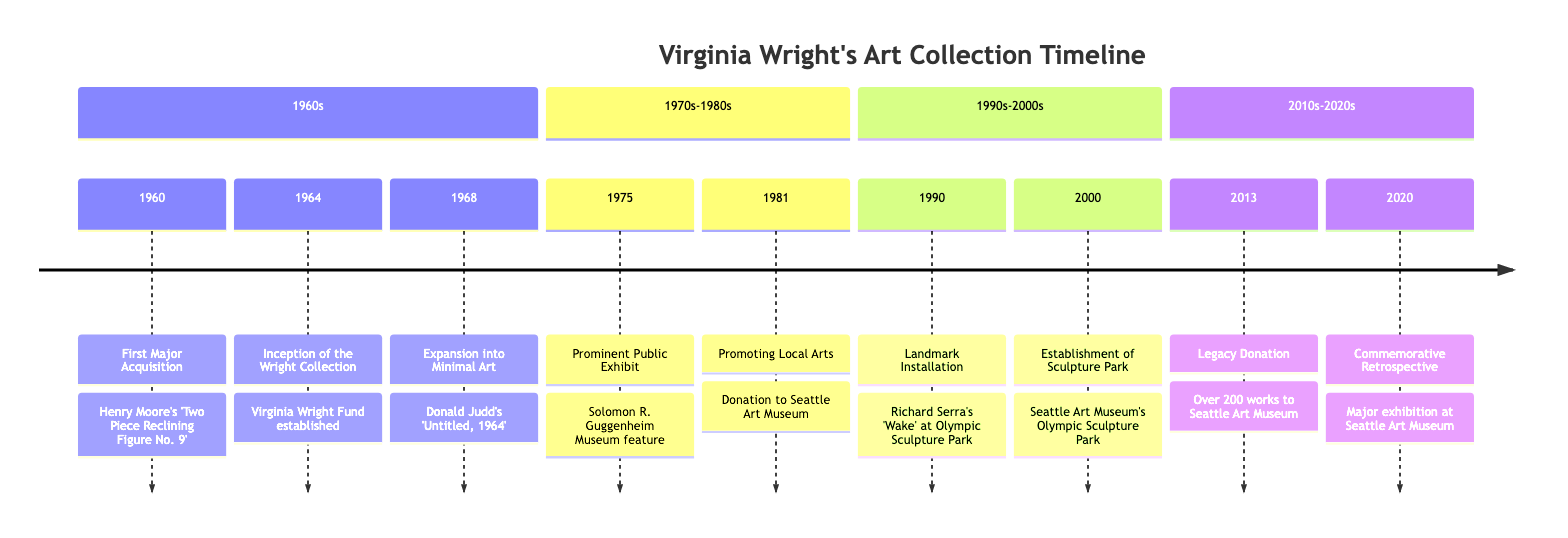What was the first major acquisition? The diagram states that the first major acquisition was Henry Moore's sculpture 'Two Piece Reclining Figure No. 9' in 1960.
Answer: Henry Moore's 'Two Piece Reclining Figure No. 9' What year marks the beginning of the Virginia Wright Fund? According to the timeline, the Virginia Wright Fund was established in 1964, which marks the inception of the Wright Collection.
Answer: 1964 How many works did Virginia donate in her legacy donation? The timeline indicates that Virginia made a historic donation of over 200 works to the Seattle Art Museum in 2013.
Answer: over 200 works Which significant minimalist piece did Virginia acquire in 1968? The diagram specifies that Virginia acquired Donald Judd's 'Untitled, 1964' in 1968, highlighting her expansion into minimal art.
Answer: Donald Judd's 'Untitled, 1964' What key event occurred in 1975? In 1975, the Solomon R. Guggenheim Museum featured key works from Wright's collection, which contributed to her national recognition.
Answer: Solomon R. Guggenheim Museum feature Which sculpture was installed in the Olympic Sculpture Park in 1990? The timeline states that Richard Serra's massive sculpture 'Wake' was installed at the Olympic Sculpture Park in 1990, funded by Virginia Wright.
Answer: Richard Serra's 'Wake' What is the significance of the Olympic Sculpture Park established in 2000? The timeline indicates that Virginia played a pivotal role in founding the Seattle Art Museum's Olympic Sculpture Park, emphasizing her legacy in the art world.
Answer: Establishment of Sculpture Park What major exhibition took place in 2020? The diagram mentions that the Seattle Art Museum hosted a major retrospective exhibition in 2020 to celebrate Virginia Wright's contributions to modern and contemporary art.
Answer: Major retrospective exhibition Which year did Virginia promote local arts through donations? According to the timeline, Virginia promoted local arts by donating significant funds to the Seattle Art Museum in 1981.
Answer: 1981 In which decade did Virginia Wright first expand her collection to include minimalist pieces? The timeline shows that Virginia Wright expanded her collection into minimalist art in the year 1968, which is in the 1960s decade.
Answer: 1960s 